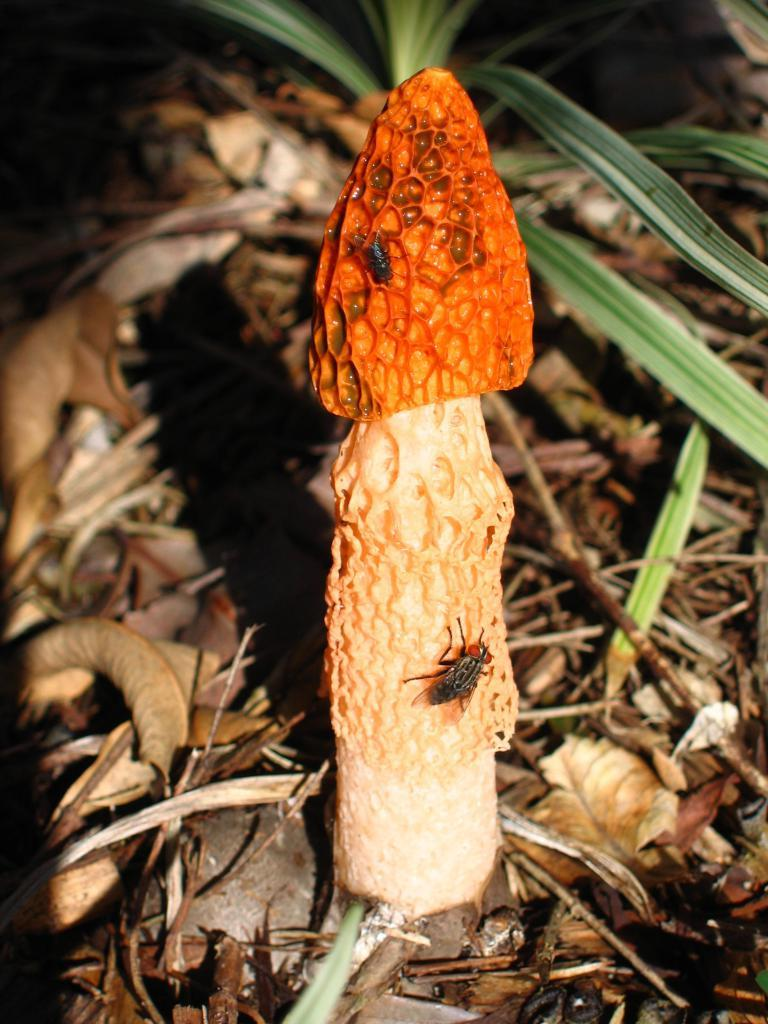What type of fungus can be seen on the ground in the image? There is an agaric on the ground in the image. What is the ground covered with, besides the agaric? The ground is covered with leaves and grass. Are there any insects present on the agaric? Yes, there are flies present on the agaric. What statement can be seen written on the cabbage in the image? There is no cabbage present in the image, and therefore no statement can be seen written on it. 